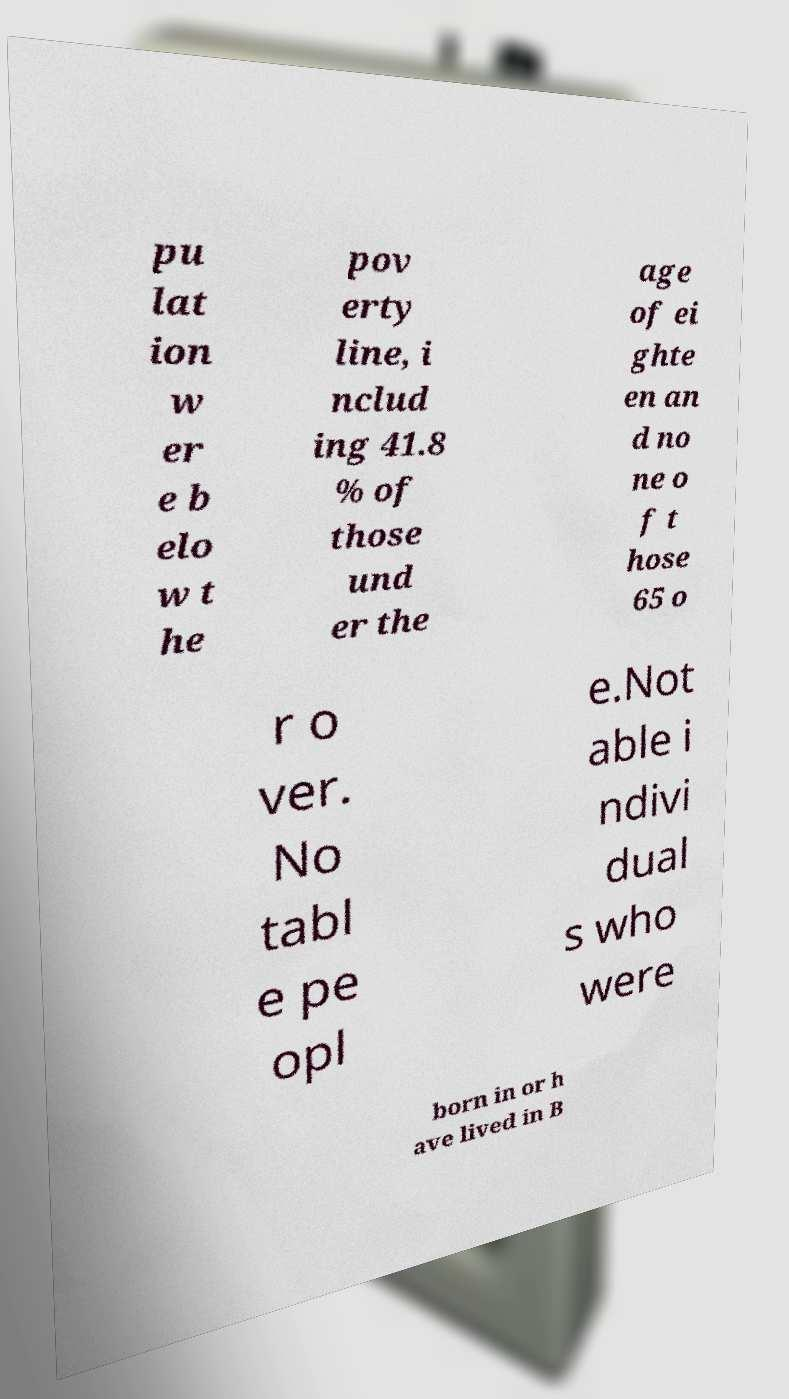What messages or text are displayed in this image? I need them in a readable, typed format. pu lat ion w er e b elo w t he pov erty line, i nclud ing 41.8 % of those und er the age of ei ghte en an d no ne o f t hose 65 o r o ver. No tabl e pe opl e.Not able i ndivi dual s who were born in or h ave lived in B 